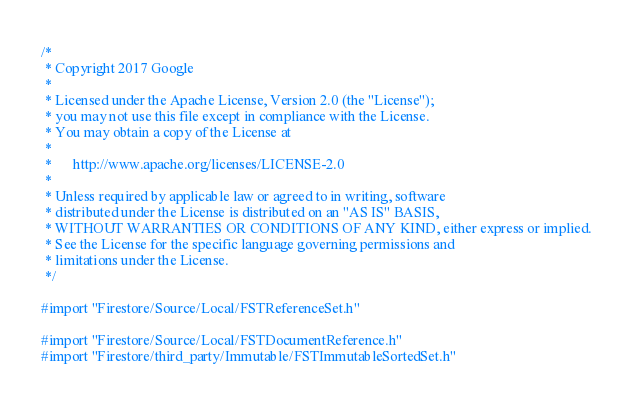<code> <loc_0><loc_0><loc_500><loc_500><_ObjectiveC_>/*
 * Copyright 2017 Google
 *
 * Licensed under the Apache License, Version 2.0 (the "License");
 * you may not use this file except in compliance with the License.
 * You may obtain a copy of the License at
 *
 *      http://www.apache.org/licenses/LICENSE-2.0
 *
 * Unless required by applicable law or agreed to in writing, software
 * distributed under the License is distributed on an "AS IS" BASIS,
 * WITHOUT WARRANTIES OR CONDITIONS OF ANY KIND, either express or implied.
 * See the License for the specific language governing permissions and
 * limitations under the License.
 */

#import "Firestore/Source/Local/FSTReferenceSet.h"

#import "Firestore/Source/Local/FSTDocumentReference.h"
#import "Firestore/third_party/Immutable/FSTImmutableSortedSet.h"
</code> 